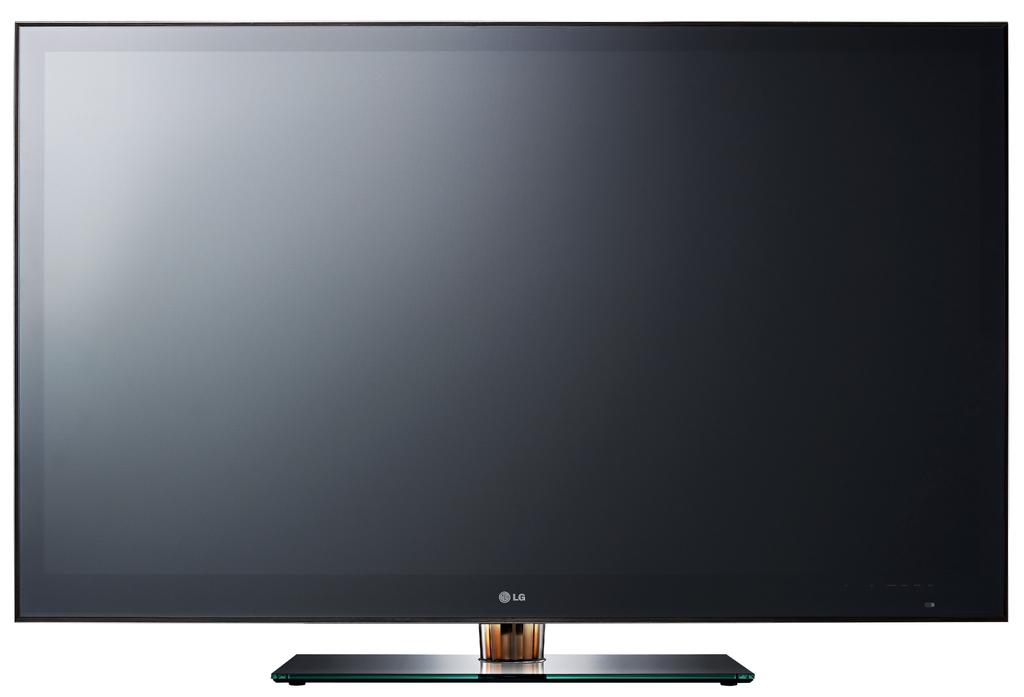<image>
Share a concise interpretation of the image provided. a television with the letters LG on it 